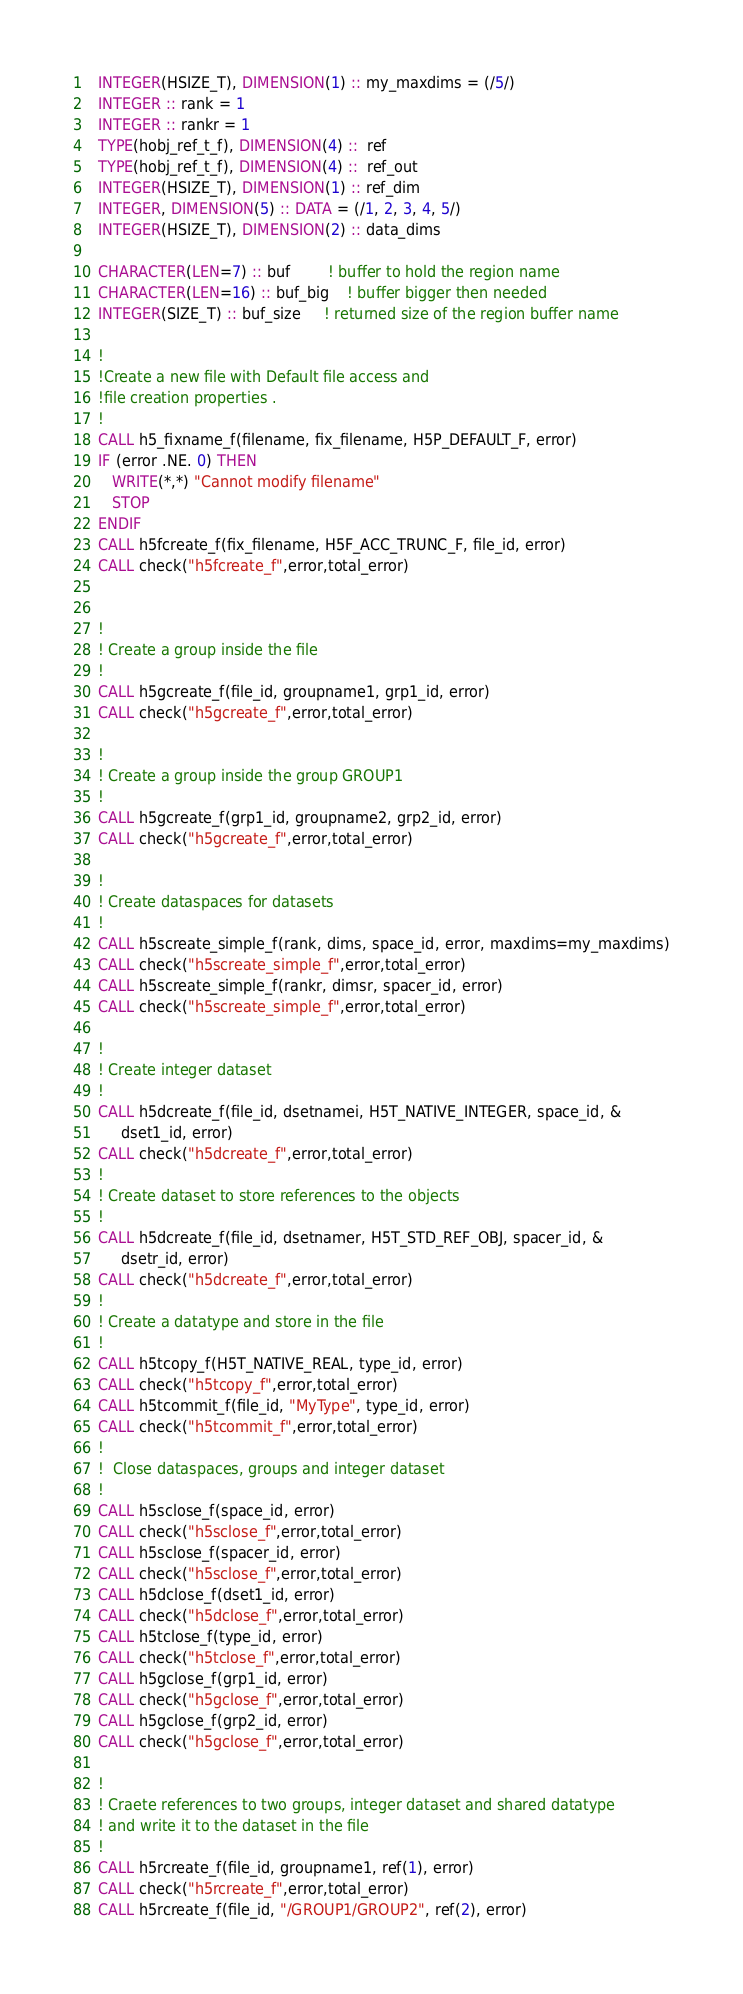Convert code to text. <code><loc_0><loc_0><loc_500><loc_500><_FORTRAN_>  INTEGER(HSIZE_T), DIMENSION(1) :: my_maxdims = (/5/)
  INTEGER :: rank = 1
  INTEGER :: rankr = 1
  TYPE(hobj_ref_t_f), DIMENSION(4) ::  ref
  TYPE(hobj_ref_t_f), DIMENSION(4) ::  ref_out
  INTEGER(HSIZE_T), DIMENSION(1) :: ref_dim
  INTEGER, DIMENSION(5) :: DATA = (/1, 2, 3, 4, 5/)
  INTEGER(HSIZE_T), DIMENSION(2) :: data_dims

  CHARACTER(LEN=7) :: buf        ! buffer to hold the region name
  CHARACTER(LEN=16) :: buf_big    ! buffer bigger then needed
  INTEGER(SIZE_T) :: buf_size     ! returned size of the region buffer name

  !
  !Create a new file with Default file access and
  !file creation properties .
  !
  CALL h5_fixname_f(filename, fix_filename, H5P_DEFAULT_F, error)
  IF (error .NE. 0) THEN
     WRITE(*,*) "Cannot modify filename"
     STOP
  ENDIF
  CALL h5fcreate_f(fix_filename, H5F_ACC_TRUNC_F, file_id, error)
  CALL check("h5fcreate_f",error,total_error)


  !
  ! Create a group inside the file
  !
  CALL h5gcreate_f(file_id, groupname1, grp1_id, error)
  CALL check("h5gcreate_f",error,total_error)

  !
  ! Create a group inside the group GROUP1
  !
  CALL h5gcreate_f(grp1_id, groupname2, grp2_id, error)
  CALL check("h5gcreate_f",error,total_error)

  !
  ! Create dataspaces for datasets
  !
  CALL h5screate_simple_f(rank, dims, space_id, error, maxdims=my_maxdims)
  CALL check("h5screate_simple_f",error,total_error)
  CALL h5screate_simple_f(rankr, dimsr, spacer_id, error)
  CALL check("h5screate_simple_f",error,total_error)

  !
  ! Create integer dataset
  !
  CALL h5dcreate_f(file_id, dsetnamei, H5T_NATIVE_INTEGER, space_id, &
       dset1_id, error)
  CALL check("h5dcreate_f",error,total_error)
  !
  ! Create dataset to store references to the objects
  !
  CALL h5dcreate_f(file_id, dsetnamer, H5T_STD_REF_OBJ, spacer_id, &
       dsetr_id, error)
  CALL check("h5dcreate_f",error,total_error)
  !
  ! Create a datatype and store in the file
  !
  CALL h5tcopy_f(H5T_NATIVE_REAL, type_id, error)
  CALL check("h5tcopy_f",error,total_error)
  CALL h5tcommit_f(file_id, "MyType", type_id, error)
  CALL check("h5tcommit_f",error,total_error)
  !
  !  Close dataspaces, groups and integer dataset
  !
  CALL h5sclose_f(space_id, error)
  CALL check("h5sclose_f",error,total_error)
  CALL h5sclose_f(spacer_id, error)
  CALL check("h5sclose_f",error,total_error)
  CALL h5dclose_f(dset1_id, error)
  CALL check("h5dclose_f",error,total_error)
  CALL h5tclose_f(type_id, error)
  CALL check("h5tclose_f",error,total_error)
  CALL h5gclose_f(grp1_id, error)
  CALL check("h5gclose_f",error,total_error)
  CALL h5gclose_f(grp2_id, error)
  CALL check("h5gclose_f",error,total_error)

  !
  ! Craete references to two groups, integer dataset and shared datatype
  ! and write it to the dataset in the file
  !
  CALL h5rcreate_f(file_id, groupname1, ref(1), error)
  CALL check("h5rcreate_f",error,total_error)
  CALL h5rcreate_f(file_id, "/GROUP1/GROUP2", ref(2), error)</code> 